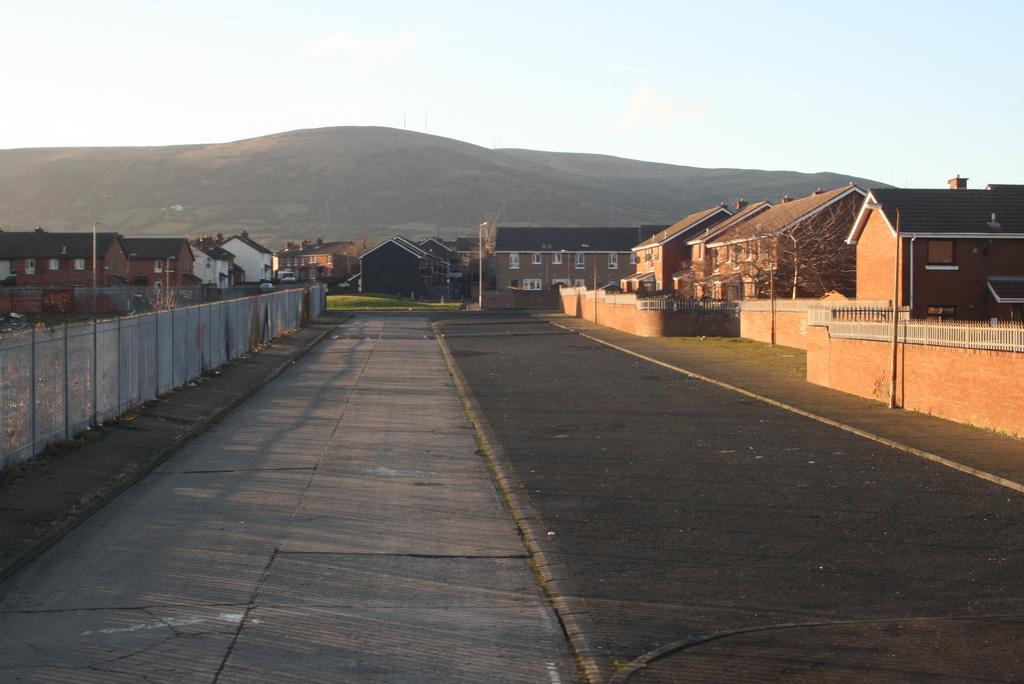How would you summarize this image in a sentence or two? In this image we can see a few houses, there are some poles, windows, trees, mountains, fence and the wall, also we can see the road and in the background we can see the sky. 